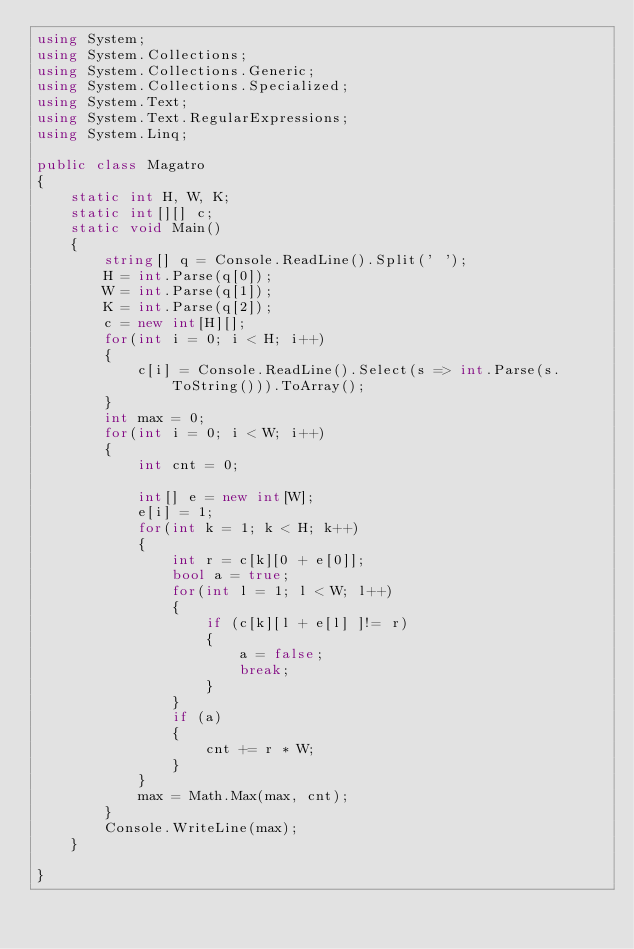<code> <loc_0><loc_0><loc_500><loc_500><_C#_>using System;
using System.Collections;
using System.Collections.Generic;
using System.Collections.Specialized;
using System.Text;
using System.Text.RegularExpressions;
using System.Linq;

public class Magatro
{
    static int H, W, K;
    static int[][] c;
    static void Main()
    {
        string[] q = Console.ReadLine().Split(' ');
        H = int.Parse(q[0]);
        W = int.Parse(q[1]);
        K = int.Parse(q[2]);
        c = new int[H][];
        for(int i = 0; i < H; i++)
        {
            c[i] = Console.ReadLine().Select(s => int.Parse(s.ToString())).ToArray();
        }
        int max = 0;
        for(int i = 0; i < W; i++)
        {
            int cnt = 0;
            
            int[] e = new int[W];
            e[i] = 1;
            for(int k = 1; k < H; k++)
            {
                int r = c[k][0 + e[0]];
                bool a = true;
                for(int l = 1; l < W; l++)
                {
                    if (c[k][l + e[l] ]!= r)
                    {
                        a = false;
                        break;
                    }
                }
                if (a)
                {
                    cnt += r * W;
                }
            }
            max = Math.Max(max, cnt);
        }
        Console.WriteLine(max);
    }
   
}


</code> 